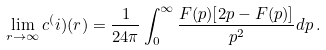Convert formula to latex. <formula><loc_0><loc_0><loc_500><loc_500>\lim _ { r \to \infty } c ^ { ( } i ) ( r ) = \frac { 1 } { 2 4 \pi } \int _ { 0 } ^ { \infty } \frac { F ( p ) [ 2 p - F ( p ) ] } { p ^ { 2 } } d p \, .</formula> 